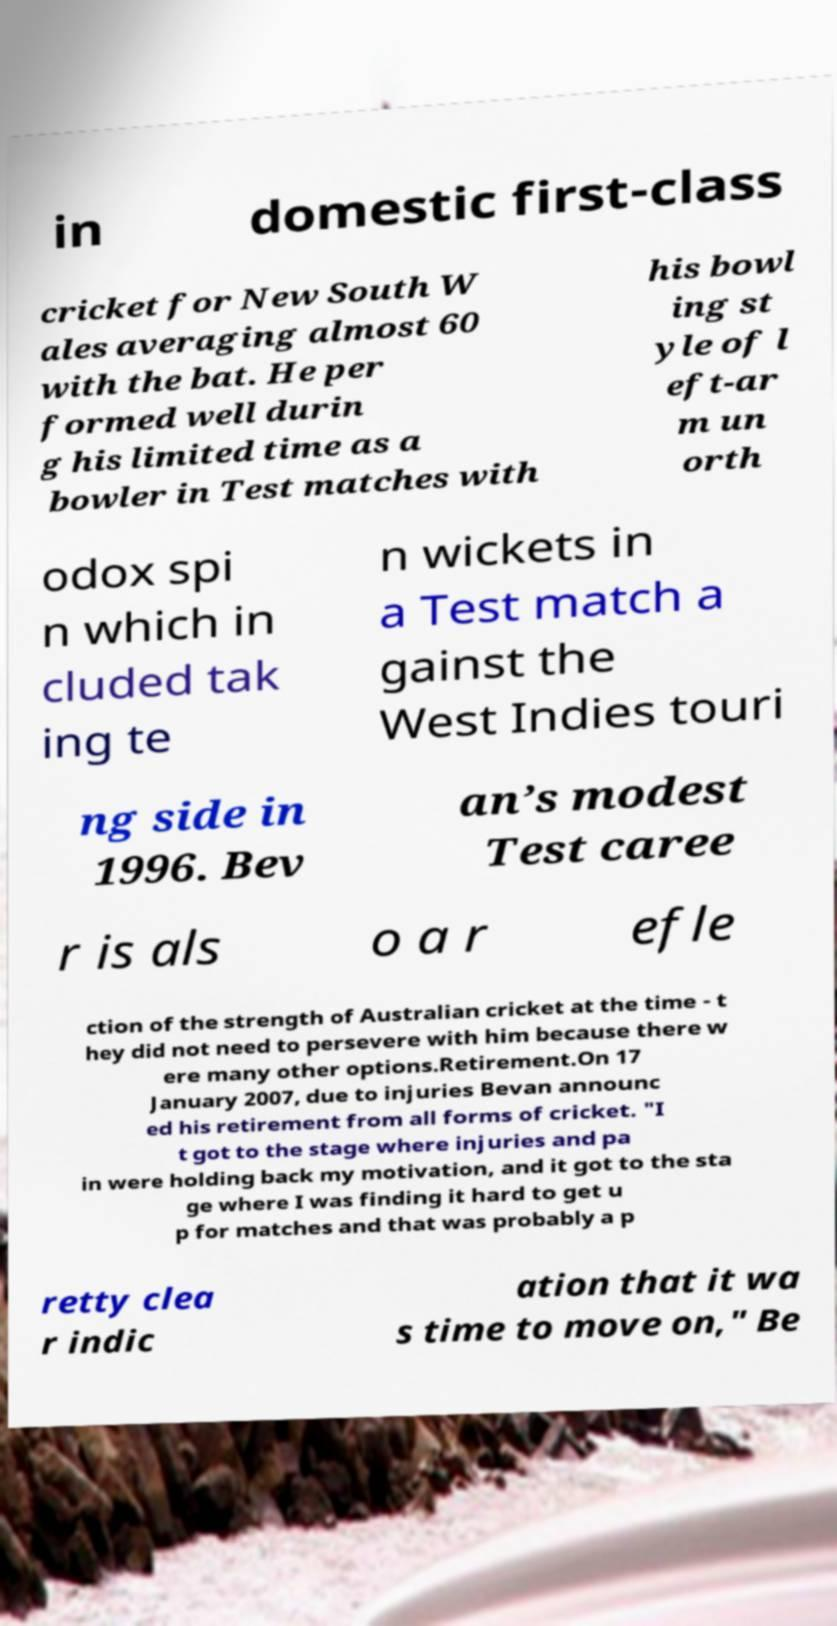I need the written content from this picture converted into text. Can you do that? in domestic first-class cricket for New South W ales averaging almost 60 with the bat. He per formed well durin g his limited time as a bowler in Test matches with his bowl ing st yle of l eft-ar m un orth odox spi n which in cluded tak ing te n wickets in a Test match a gainst the West Indies touri ng side in 1996. Bev an’s modest Test caree r is als o a r efle ction of the strength of Australian cricket at the time - t hey did not need to persevere with him because there w ere many other options.Retirement.On 17 January 2007, due to injuries Bevan announc ed his retirement from all forms of cricket. "I t got to the stage where injuries and pa in were holding back my motivation, and it got to the sta ge where I was finding it hard to get u p for matches and that was probably a p retty clea r indic ation that it wa s time to move on," Be 